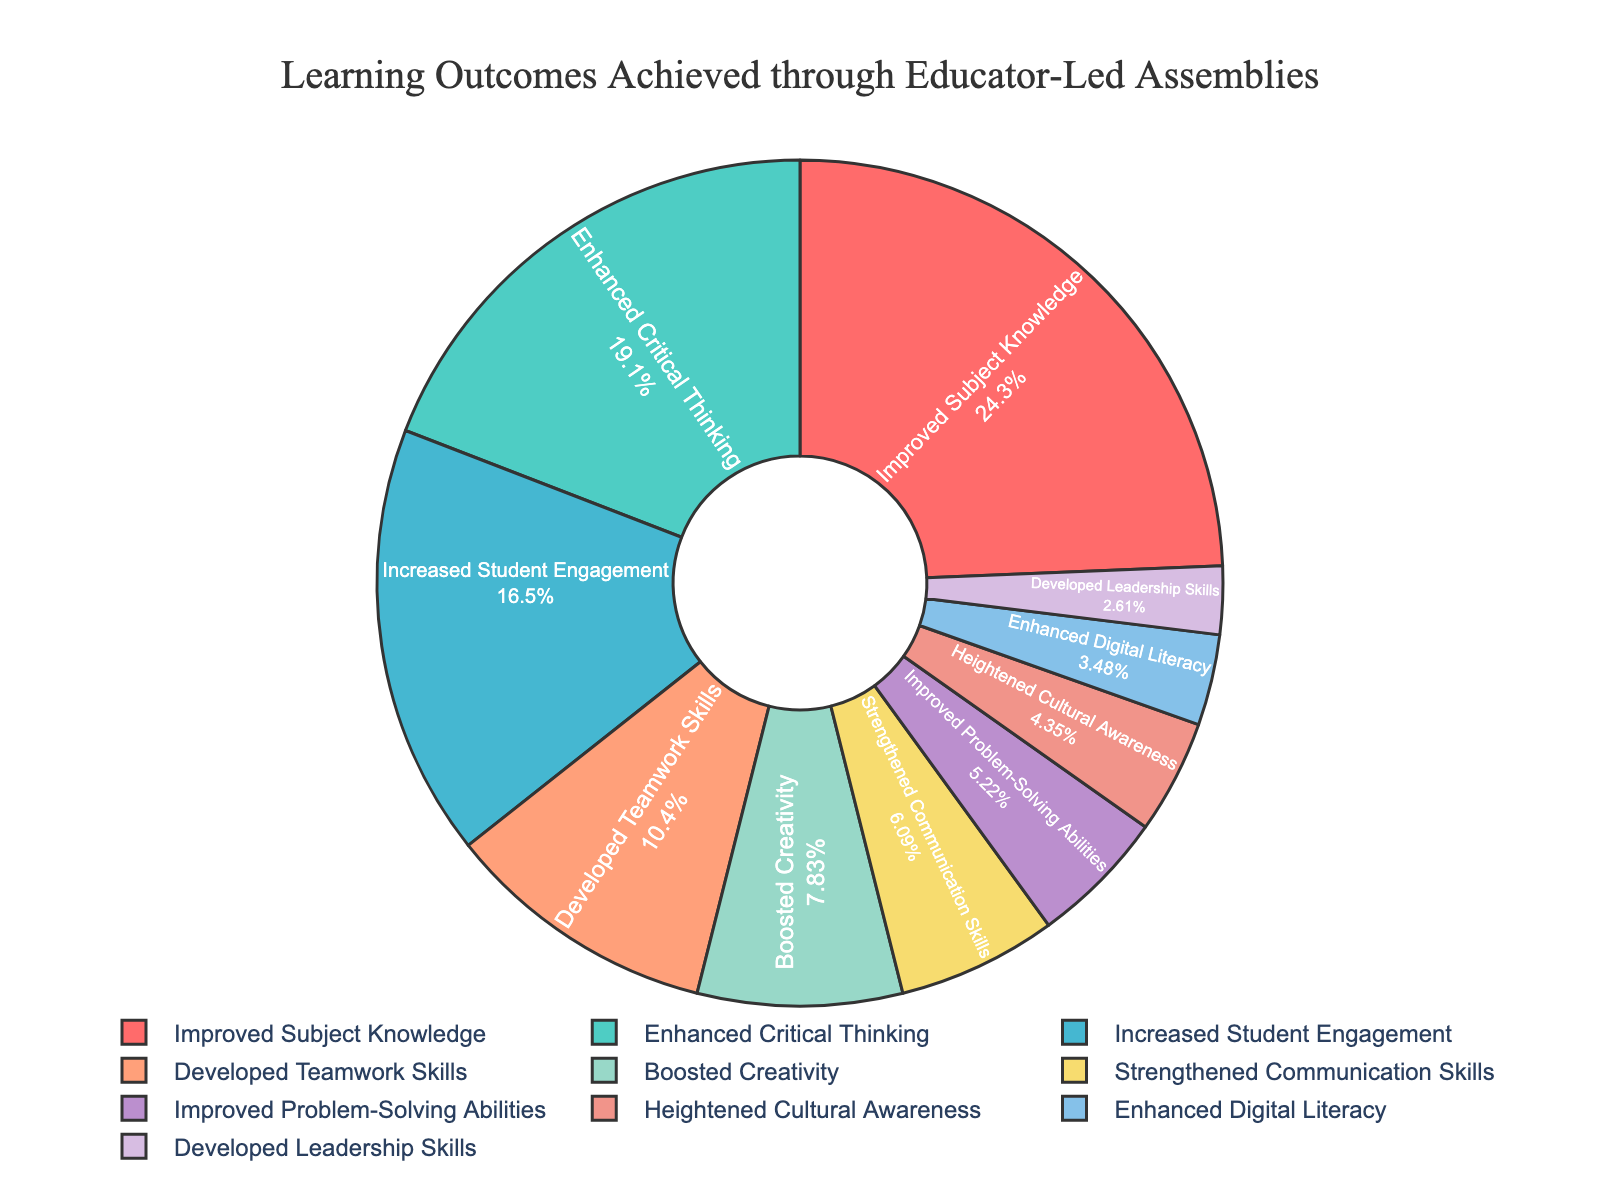What percentage of students achieved Improved Subject Knowledge? The figure shows that the section labeled "Improved Subject Knowledge" occupies 28% of the chart. This percentage indicates the proportion of students who achieved this outcome.
Answer: 28% Which learning outcome is the least achieved? By examining the smallest section of the pie chart, labeled "Developed Leadership Skills," we see that this outcome accounts for the lowest percentage, 3%.
Answer: Developed Leadership Skills How much more percentage is associated with Enhanced Critical Thinking compared to Boosted Creativity? From the pie chart, Enhanced Critical Thinking is 22% and Boosted Creativity is 9%. The difference is calculated by subtracting the percentage of Boosted Creativity from Enhanced Critical Thinking, which is 22% - 9% = 13%.
Answer: 13% What are the combined percentages for Improved Subject Knowledge and Enhanced Critical Thinking? The percentages for Improved Subject Knowledge and Enhanced Critical Thinking are 28% and 22% respectively. Adding these two percentages together gives 28% + 22% = 50%.
Answer: 50% Which learning outcome has a higher percentage: Increased Student Engagement or Developed Teamwork Skills? The pie chart shows that Increased Student Engagement is 19% while Developed Teamwork Skills is 12%. A comparison between the two values indicates that Increased Student Engagement has a higher percentage.
Answer: Increased Student Engagement If you combine the percentages for Improved Subject Knowledge, Enhanced Critical Thinking, and Increased Student Engagement, what is the total? Adding the percentages for Improved Subject Knowledge (28%), Enhanced Critical Thinking (22%), and Increased Student Engagement (19%) results in 28% + 22% + 19% = 69%.
Answer: 69% What is the visual difference in the size of the sections for Boosted Creativity and Strengthened Communication Skills? The chart shows that Boosted Creativity is represented by a slightly larger segment (9%) compared to Strengthened Communication Skills (7%).
Answer: Boosted Creativity is larger Which outcomes together constitute a majority of the pie chart? A majority is over 50%. Adding the top outcomes by their percentages: Improved Subject Knowledge (28%) + Enhanced Critical Thinking (22%) = 50%. Including Increased Student Engagement (19%) puts the combined total at 69%, which is a majority.
Answer: Improved Subject Knowledge, Enhanced Critical Thinking, and Increased Student Engagement Is the percentage of Developed Teamwork Skills higher or lower than the total of Strengthened Communication Skills and Improved Problem-Solving Abilities? Developed Teamwork Skills is 12%. Strengthened Communication Skills (7%) and Improved Problem-Solving Abilities (6%) together are 7% + 6% = 13%. Since 12% is less than 13%, Developed Teamwork Skills is lower.
Answer: Lower 